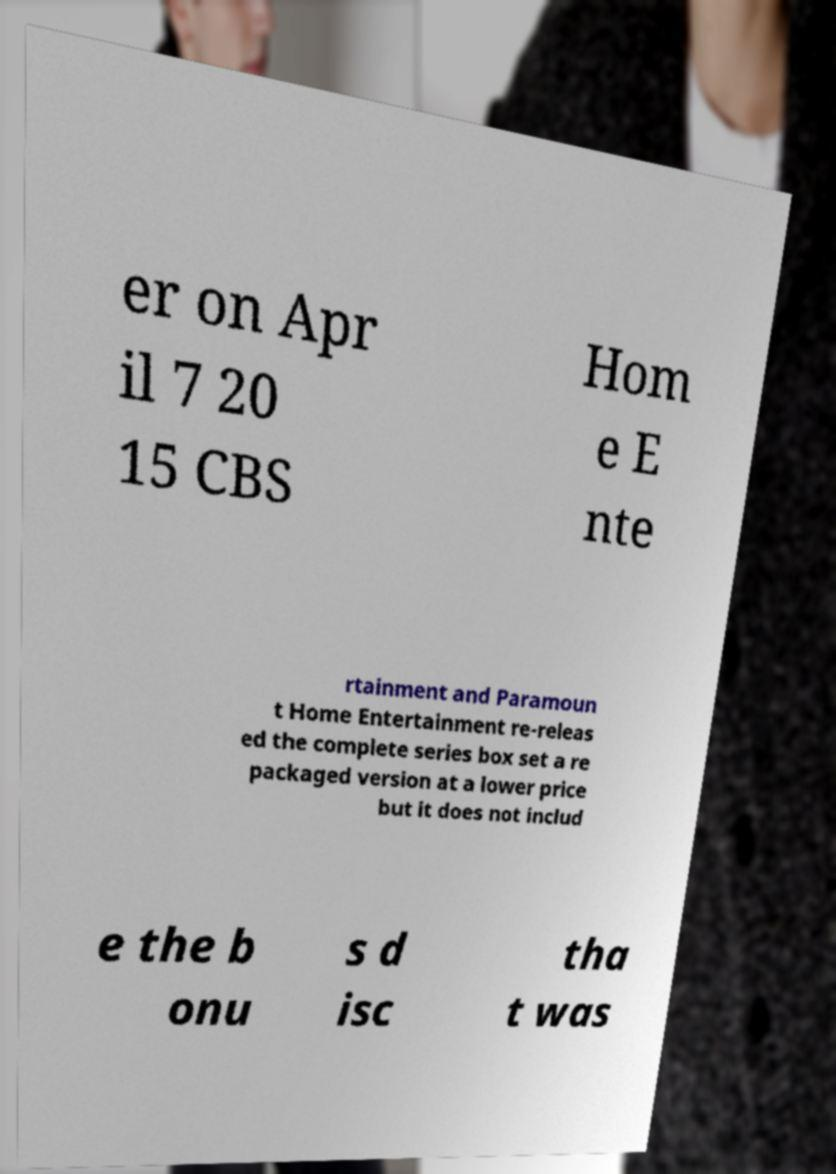What messages or text are displayed in this image? I need them in a readable, typed format. er on Apr il 7 20 15 CBS Hom e E nte rtainment and Paramoun t Home Entertainment re-releas ed the complete series box set a re packaged version at a lower price but it does not includ e the b onu s d isc tha t was 